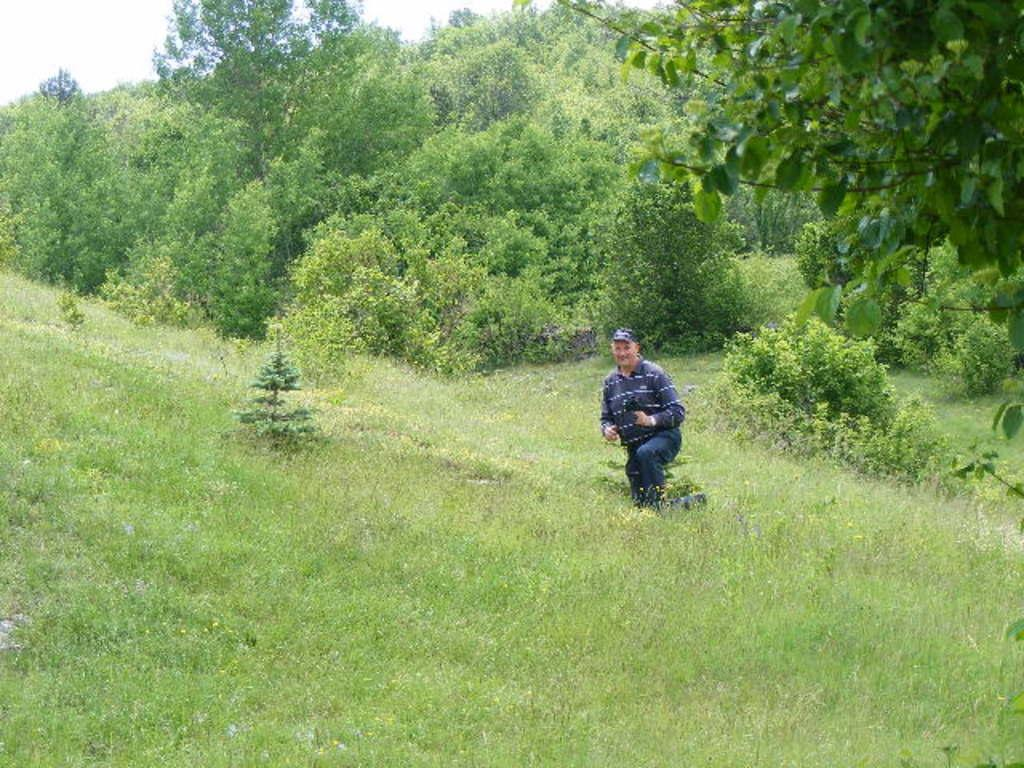What is the main subject in the foreground of the image? There is a man in the foreground of the image. What is the man doing in the image? The man is kneeling down on the grass. What can be seen on the right top of the image? There is a tree on the right top of the image. What is visible in the background of the image? There are trees and the sky visible in the background of the image. What type of substance is being extracted from the hill in the image? There is no hill or substance extraction present in the image. 